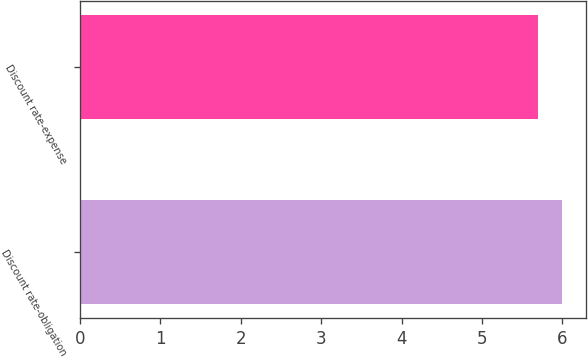<chart> <loc_0><loc_0><loc_500><loc_500><bar_chart><fcel>Discount rate-obligation<fcel>Discount rate-expense<nl><fcel>6<fcel>5.7<nl></chart> 